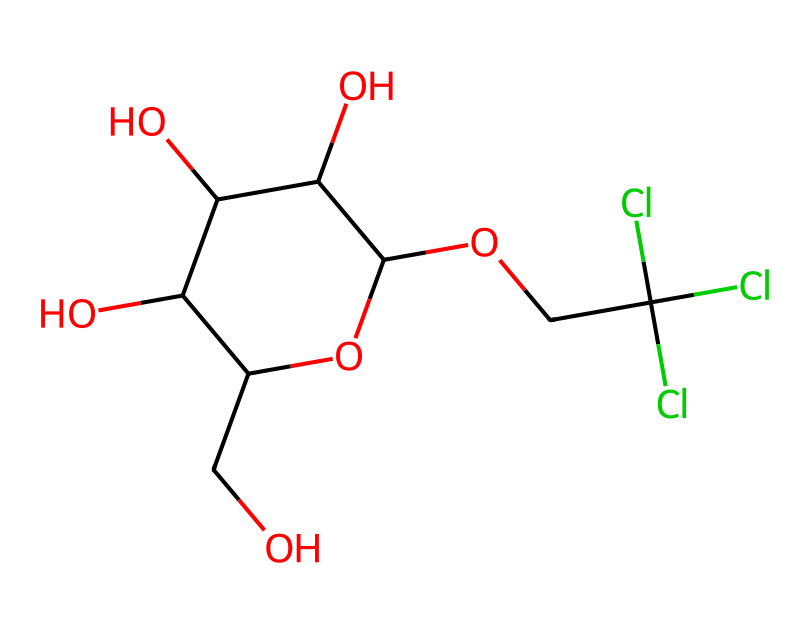What is the total number of carbon atoms in this chemical? By inspecting the provided SMILES representation, we count the total number of 'C' characters, which represent carbon atoms. In this case, there are 8 carbon atoms indicated.
Answer: 8 How many hydroxyl groups (-OH) are present in this molecule? The SMILES representation contains multiple occurrences of 'O' that are connected to hydrogen atoms, indicating hydroxyl groups. By analyzing the structure, we find 4 hydroxyl groups.
Answer: 4 Is this structure a sugar alcohol? A sugar alcohol is characterized by the presence of multiple hydroxyl groups with a general structure derived from sugars. The presence of several hydroxyl (-OH) groups and a cyclic structure suggests that it exhibits properties of a sugar alcohol.
Answer: Yes What type of functional groups are present in this chemical? By examining the structure, we can identify hydroxyl (OH) groups and a chlorinated group represented by the presence of chlorine atoms. These groups categorize the chemical into specific functional types common in food additives.
Answer: Hydroxyl and chlorinated groups Can this compound be classified as a low-calorie sweetener? The presence of multiple hydroxyl groups indicates the molecule's ability to mimic sweetness without providing significant calories. This characteristic is typical of many low-calorie sweeteners, confirming its classification.
Answer: Yes 